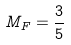Convert formula to latex. <formula><loc_0><loc_0><loc_500><loc_500>M _ { F } = \frac { 3 } { 5 }</formula> 